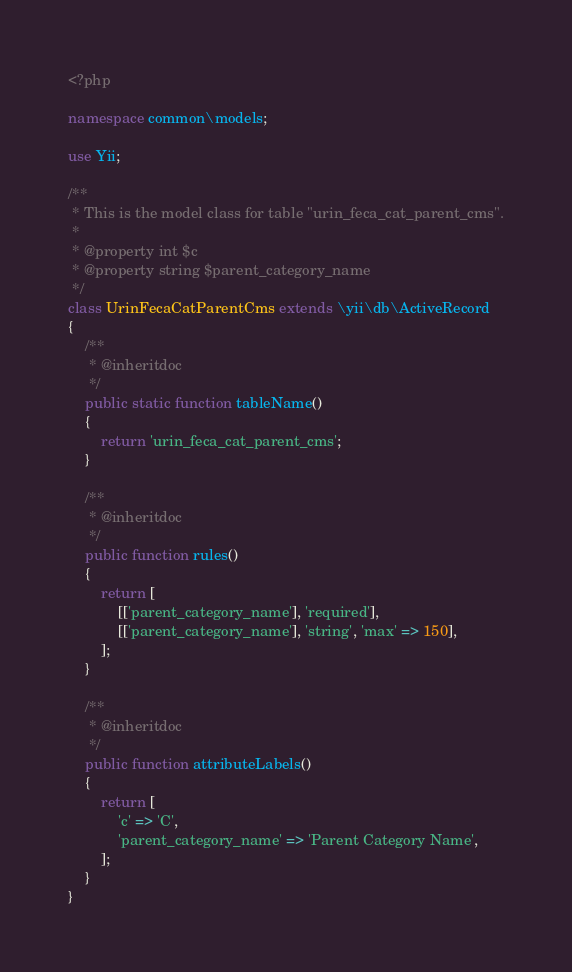<code> <loc_0><loc_0><loc_500><loc_500><_PHP_><?php

namespace common\models;

use Yii;

/**
 * This is the model class for table "urin_feca_cat_parent_cms".
 *
 * @property int $c
 * @property string $parent_category_name
 */
class UrinFecaCatParentCms extends \yii\db\ActiveRecord
{
    /**
     * @inheritdoc
     */
    public static function tableName()
    {
        return 'urin_feca_cat_parent_cms';
    }

    /**
     * @inheritdoc
     */
    public function rules()
    {
        return [
            [['parent_category_name'], 'required'],
            [['parent_category_name'], 'string', 'max' => 150],
        ];
    }

    /**
     * @inheritdoc
     */
    public function attributeLabels()
    {
        return [
            'c' => 'C',
            'parent_category_name' => 'Parent Category Name',
        ];
    }
}
</code> 